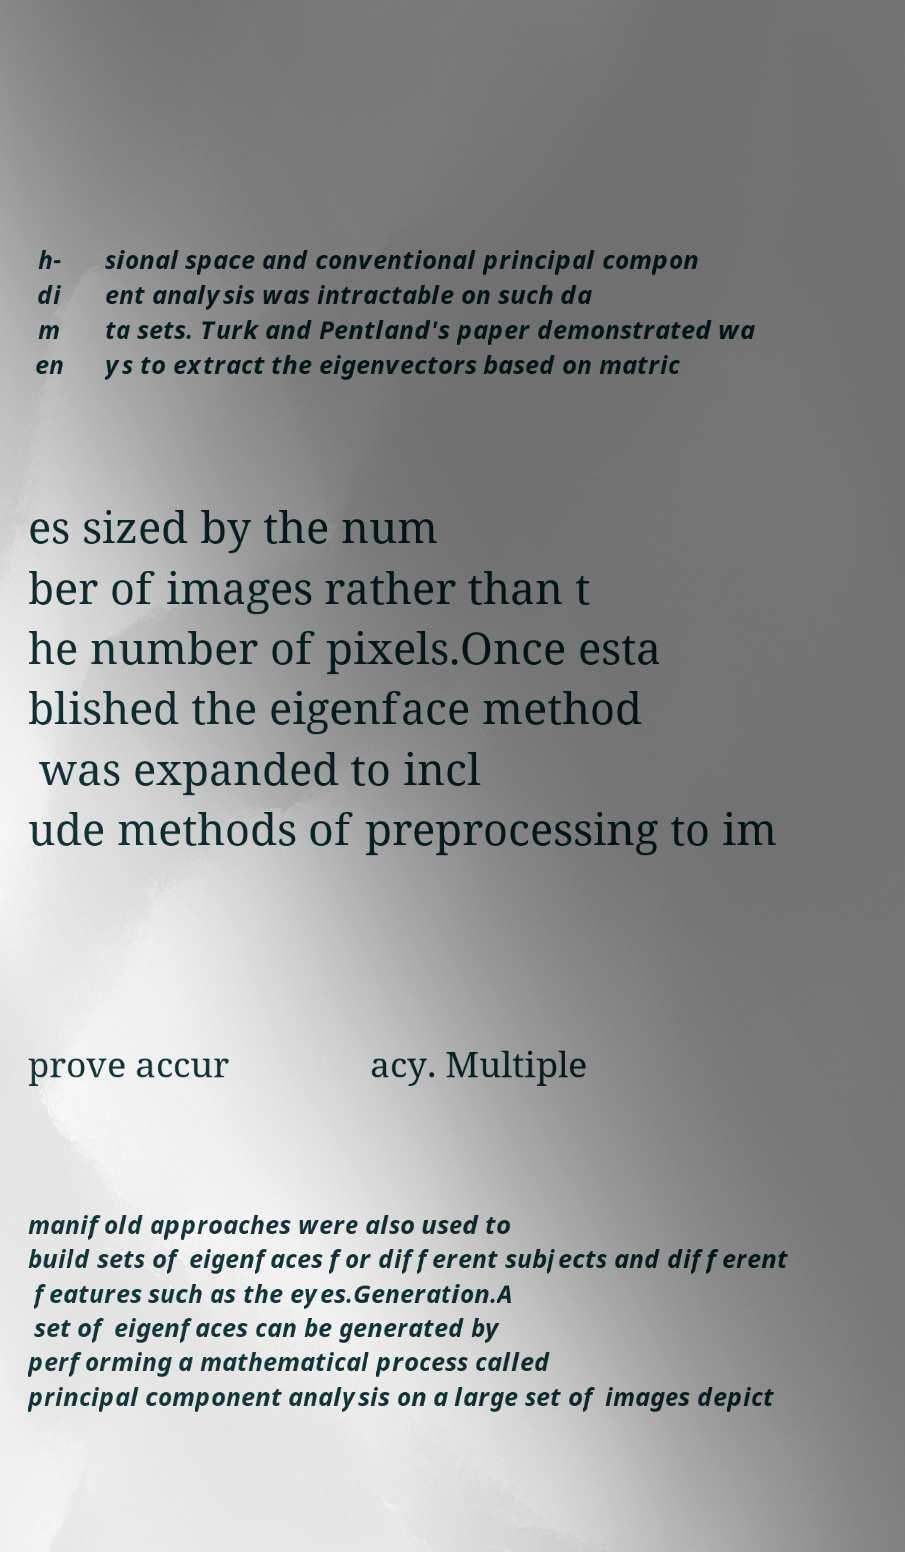What messages or text are displayed in this image? I need them in a readable, typed format. h- di m en sional space and conventional principal compon ent analysis was intractable on such da ta sets. Turk and Pentland's paper demonstrated wa ys to extract the eigenvectors based on matric es sized by the num ber of images rather than t he number of pixels.Once esta blished the eigenface method was expanded to incl ude methods of preprocessing to im prove accur acy. Multiple manifold approaches were also used to build sets of eigenfaces for different subjects and different features such as the eyes.Generation.A set of eigenfaces can be generated by performing a mathematical process called principal component analysis on a large set of images depict 